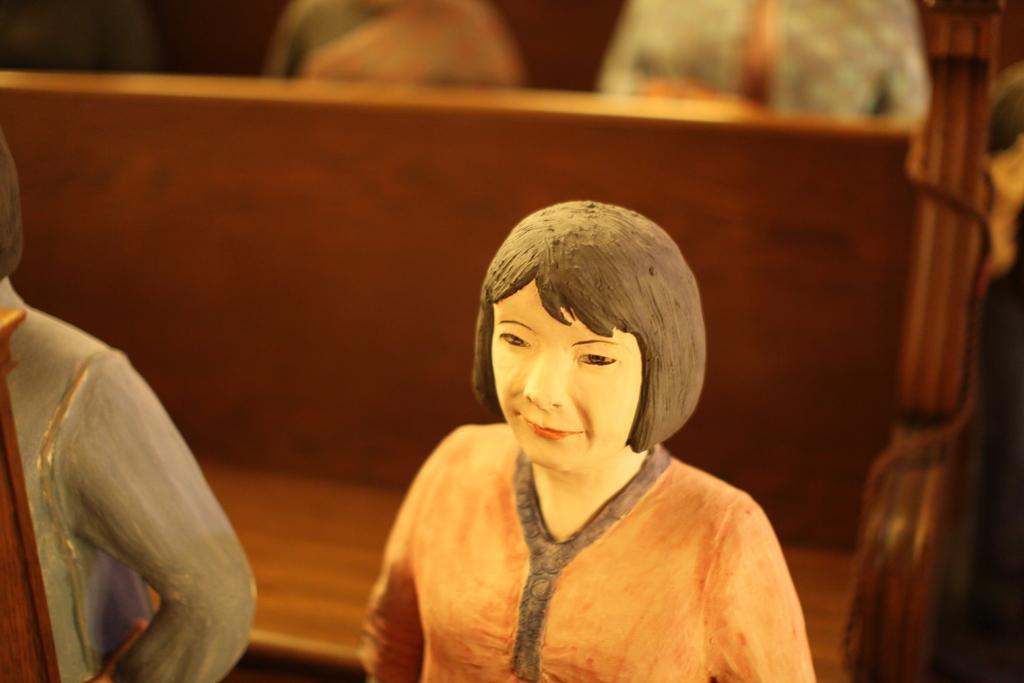Describe this image in one or two sentences. There are statues of people. In the back there is a bench. 